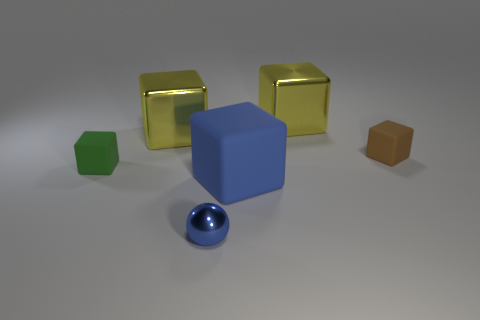Subtract all brown blocks. How many blocks are left? 4 Subtract all brown rubber blocks. How many blocks are left? 4 Subtract 1 blocks. How many blocks are left? 4 Subtract all red blocks. Subtract all yellow balls. How many blocks are left? 5 Add 2 tiny metallic balls. How many objects exist? 8 Subtract all cubes. How many objects are left? 1 Add 4 metal objects. How many metal objects exist? 7 Subtract 0 red blocks. How many objects are left? 6 Subtract all large blue matte things. Subtract all tiny blue objects. How many objects are left? 4 Add 2 small rubber things. How many small rubber things are left? 4 